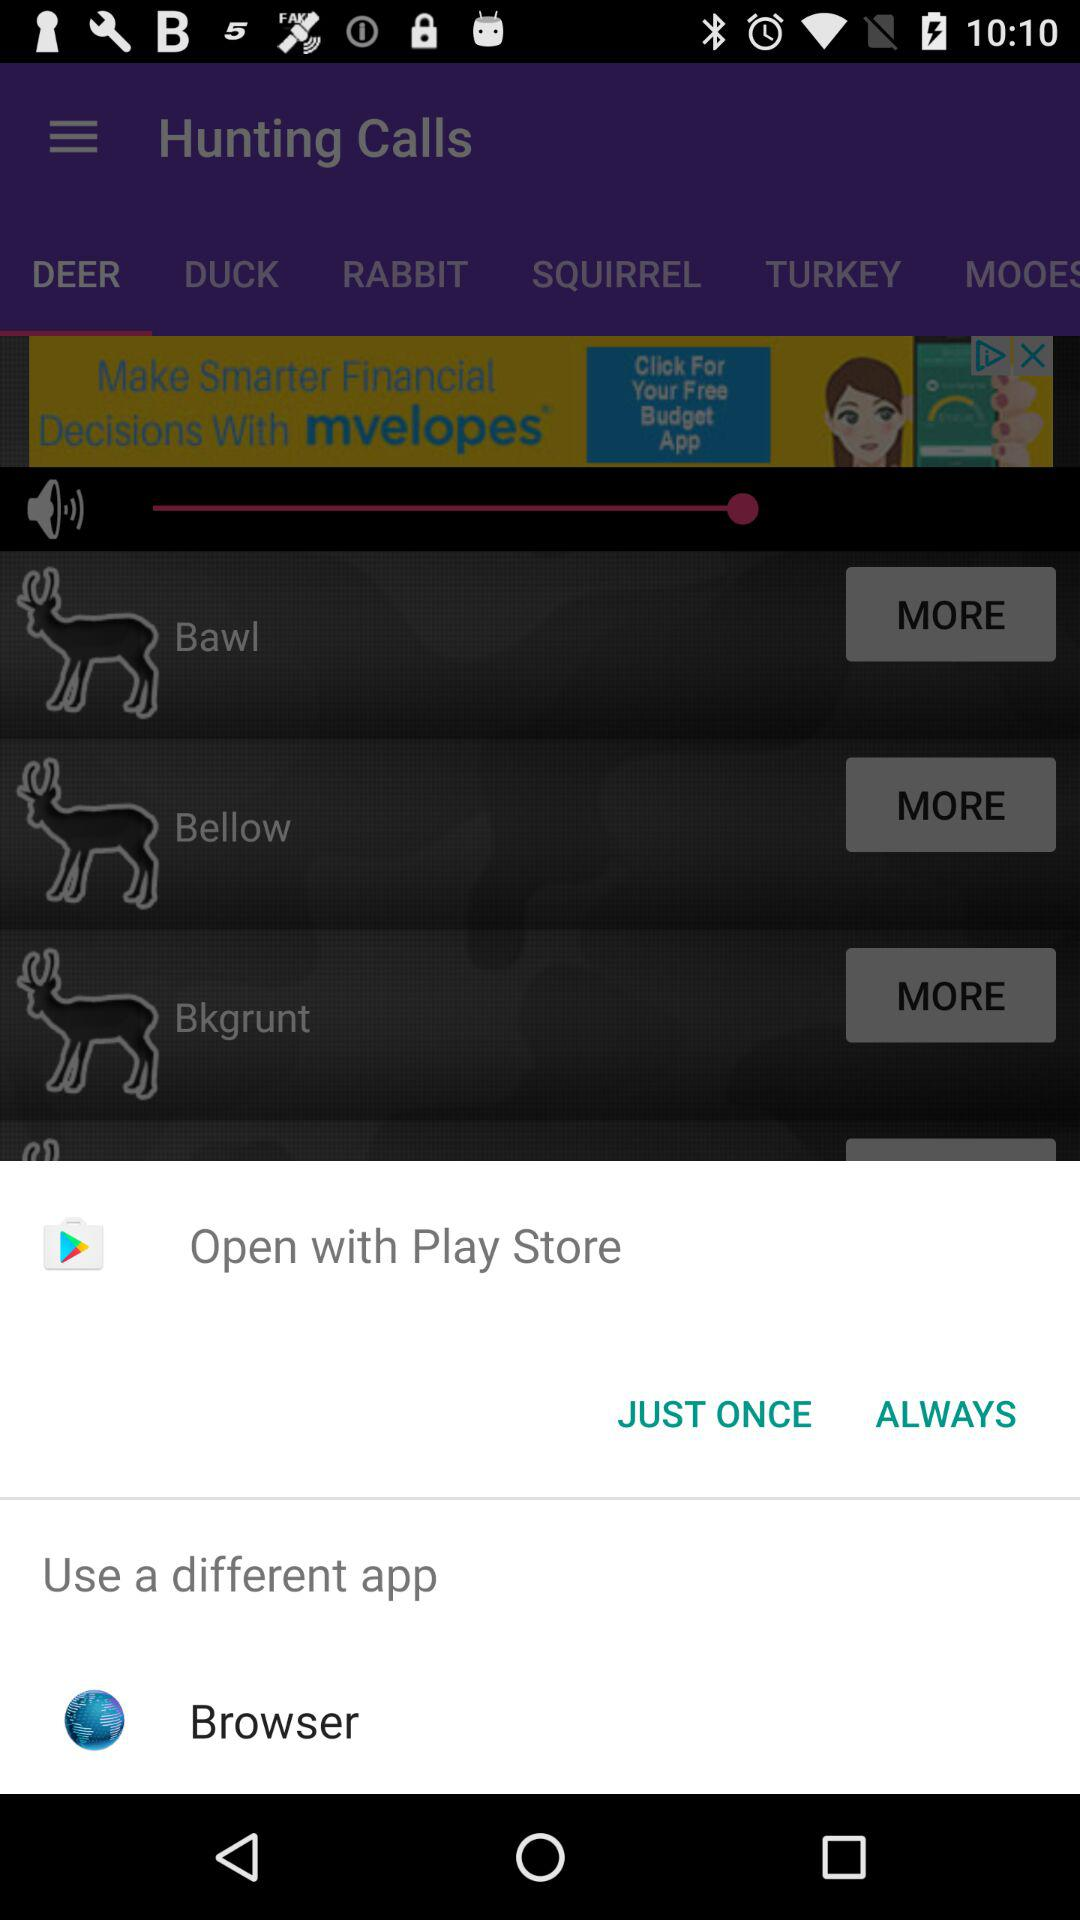What are the options available to open with? The available options are "Play Store" and "Browser". 